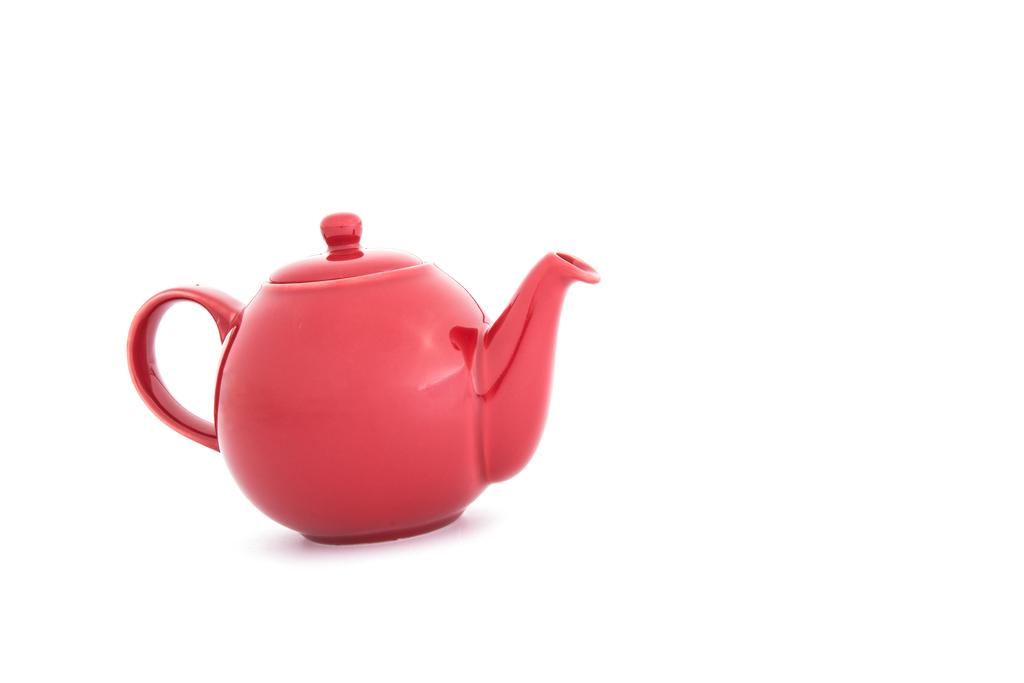What is the color of the kettle in the image? The kettle in the image is red. What is the color of the surface on which the kettle is placed? The surface is white. What color is the background of the image? The background of the image is white. What historical event is depicted in the image? There is no historical event depicted in the image; it features a red kettle on a white surface with a white background. What type of beam is supporting the kettle in the image? There is no beam present in the image; the kettle is placed on a white surface. 